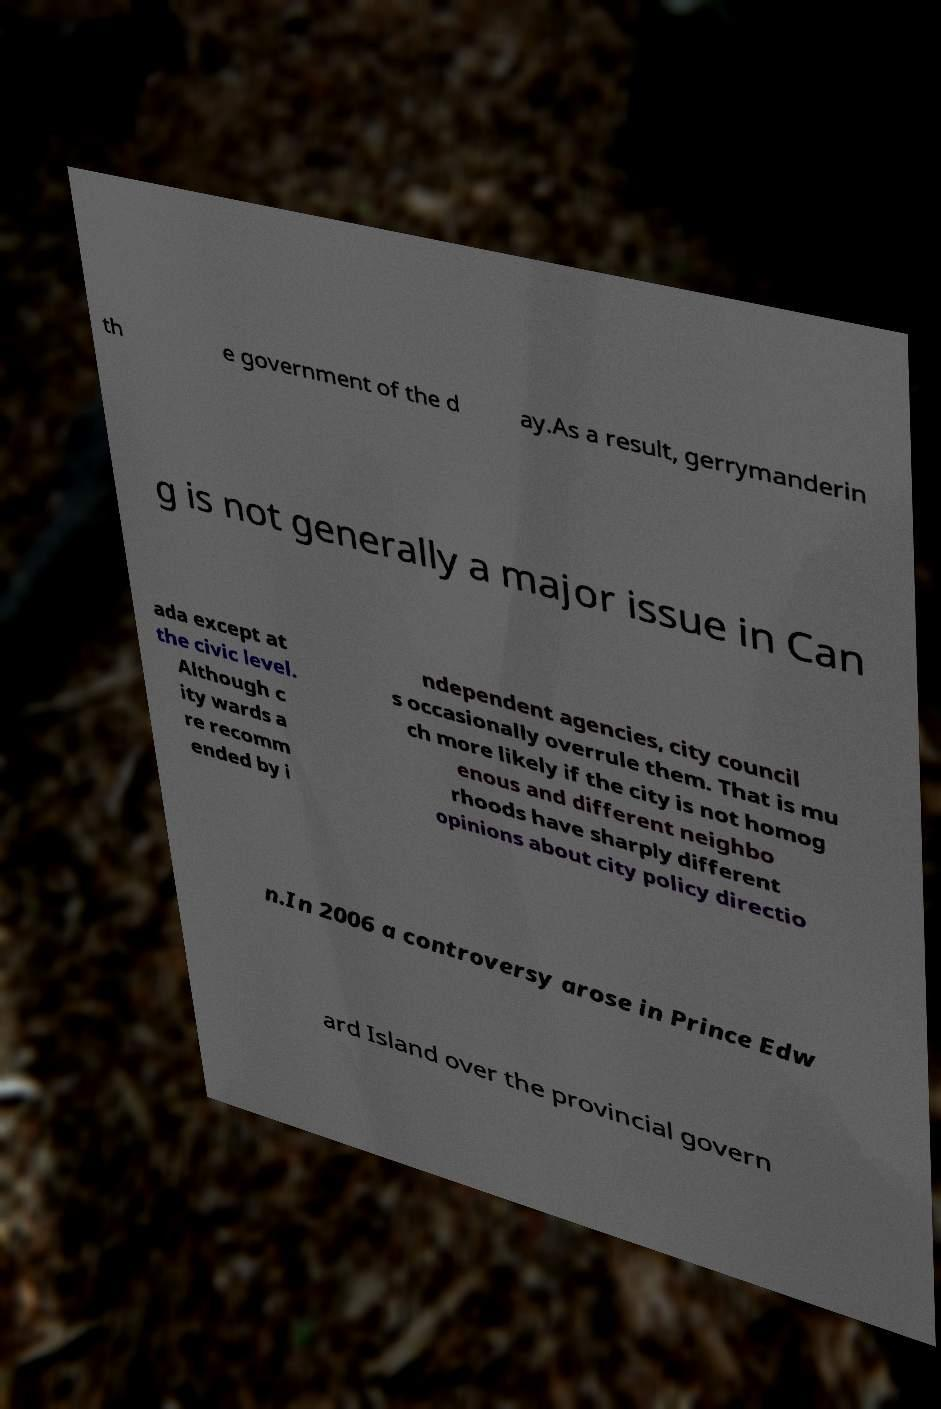For documentation purposes, I need the text within this image transcribed. Could you provide that? th e government of the d ay.As a result, gerrymanderin g is not generally a major issue in Can ada except at the civic level. Although c ity wards a re recomm ended by i ndependent agencies, city council s occasionally overrule them. That is mu ch more likely if the city is not homog enous and different neighbo rhoods have sharply different opinions about city policy directio n.In 2006 a controversy arose in Prince Edw ard Island over the provincial govern 